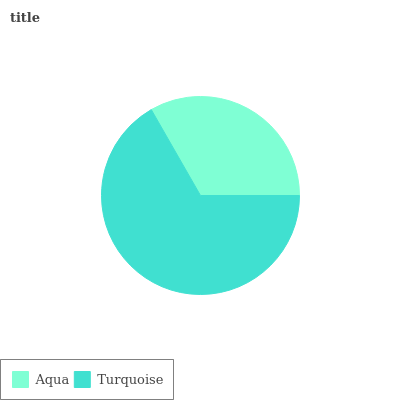Is Aqua the minimum?
Answer yes or no. Yes. Is Turquoise the maximum?
Answer yes or no. Yes. Is Turquoise the minimum?
Answer yes or no. No. Is Turquoise greater than Aqua?
Answer yes or no. Yes. Is Aqua less than Turquoise?
Answer yes or no. Yes. Is Aqua greater than Turquoise?
Answer yes or no. No. Is Turquoise less than Aqua?
Answer yes or no. No. Is Turquoise the high median?
Answer yes or no. Yes. Is Aqua the low median?
Answer yes or no. Yes. Is Aqua the high median?
Answer yes or no. No. Is Turquoise the low median?
Answer yes or no. No. 